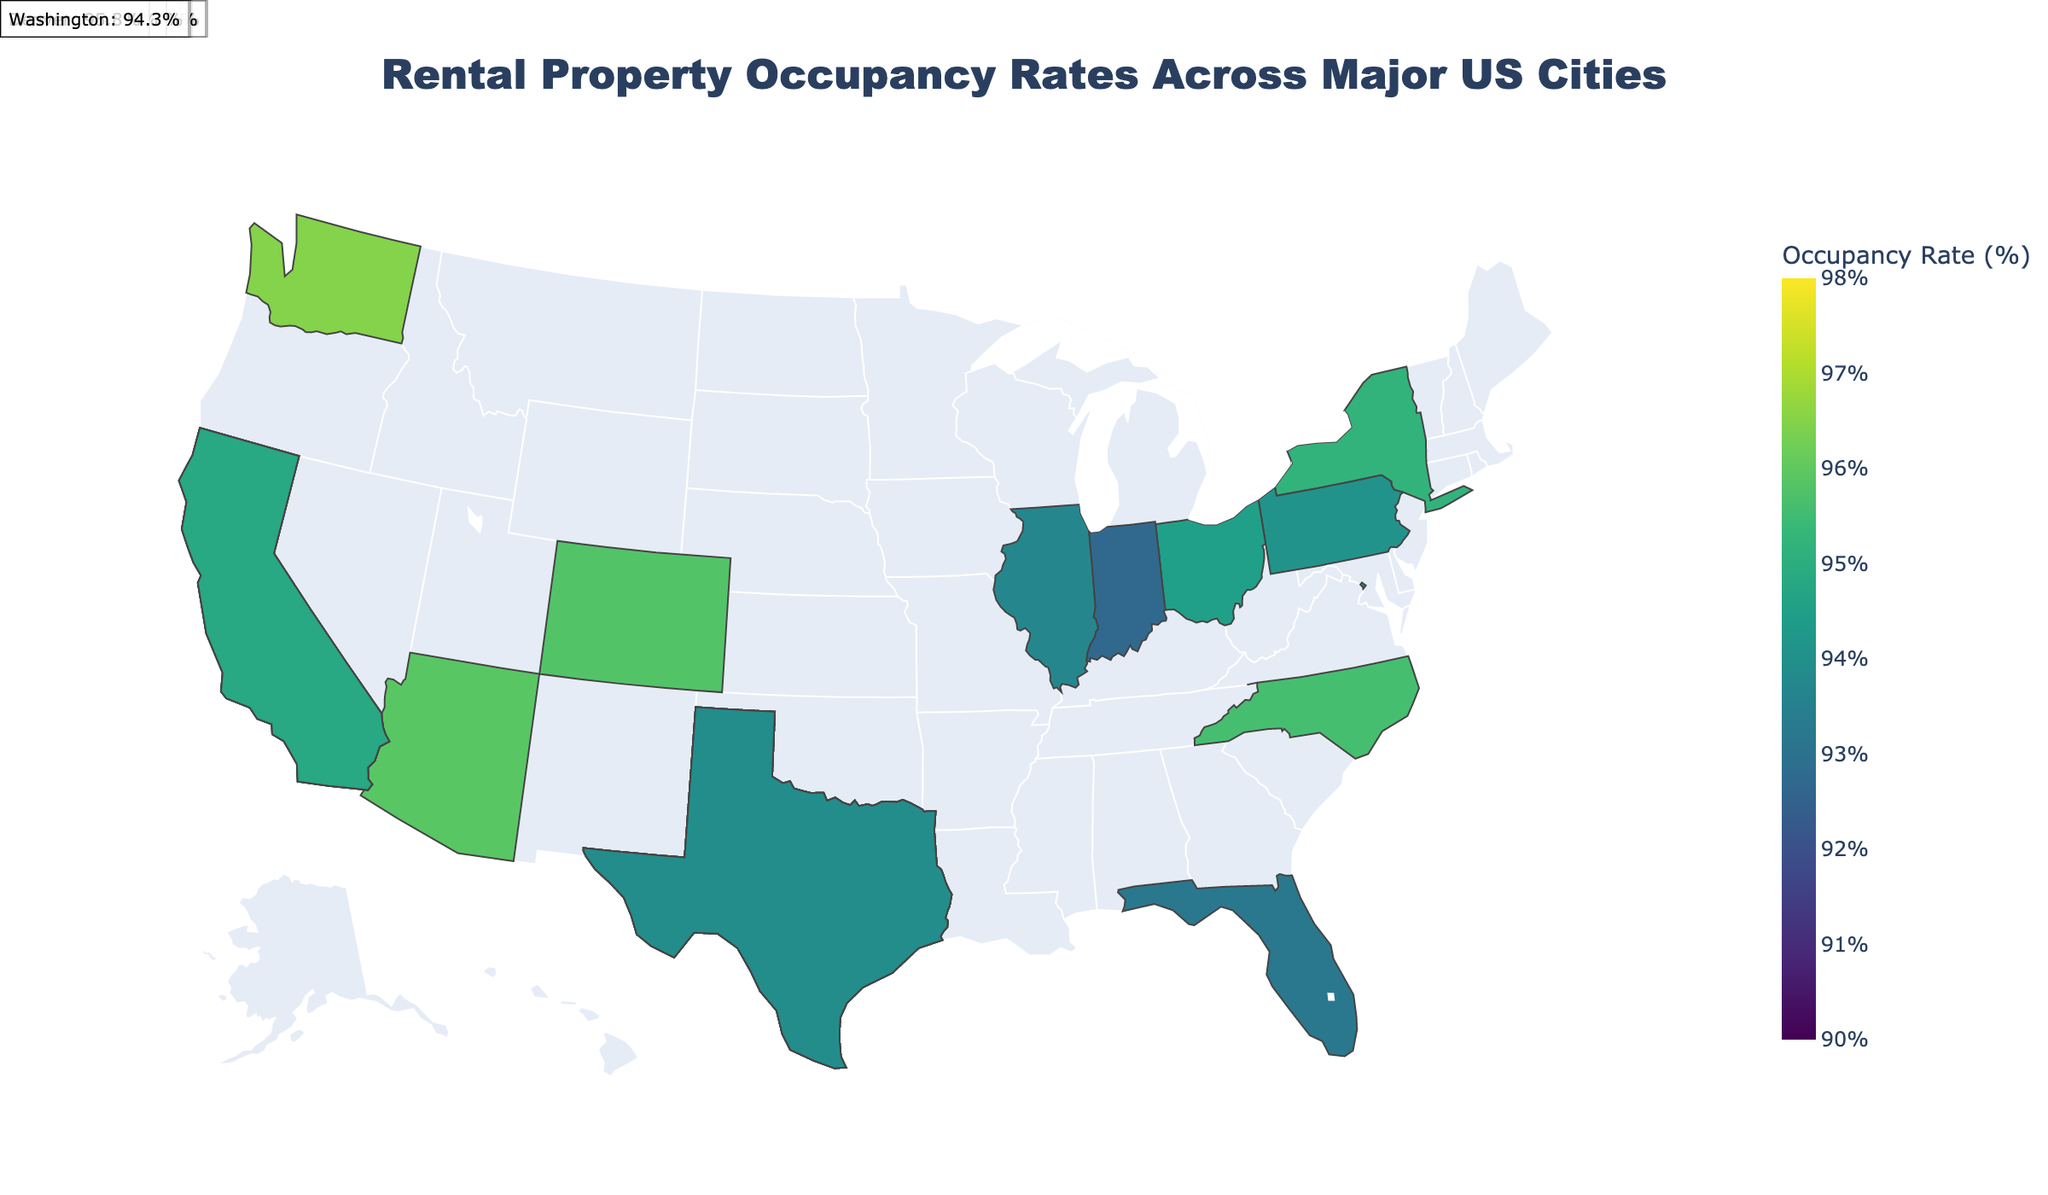what is the title of the plot? The title is displayed prominently at the top of the plot, it reads: "Rental Property Occupancy Rates Across Major US Cities".
Answer: Rental Property Occupancy Rates Across Major US Cities What state has the city with the highest rental property occupancy rate? The highest rental property occupancy rate, 97.3%, belongs to San Diego. The plot shows that San Diego is in California.
Answer: California Which city has the lowest occupancy rate, and what is the rate? By examining the annotations on the map, we see that the lowest occupancy rate is in Houston, TX, which has an occupancy rate of 91.5%.
Answer: Houston, TX, 91.5% How many cities have a rental property occupancy rate above 95%? We count the cities with rentals above 95%: Los Angeles (96.8), Phoenix (95.9), San Diego (97.3), San Jose (96.1), Austin (95.4), Charlotte (95.6), Seattle (96.5), and Denver (95.8).
Answer: 8 cities Which state has the most cities represented on the map and how many? We identify each state and count the cities: Texas has the most cities represented with Houston, San Antonio, Dallas, Fort Worth, and Austin. That's a total of 5 cities.
Answer: Texas, 5 Is the rental property occupancy rate higher on the East Coast or the West Coast? Average the occupancy rates for East Coast cities (New York City: 95.2, Philadelphia: 94.1, Washington DC: 94.3), and West Coast cities (Los Angeles: 96.8, San Diego: 97.3, San Francisco: 94.8, San Jose: 96.1, Seattle: 96.5): 
East Coast avg = (95.2 + 94.1 + 94.3) / 3 = 94.53
West Coast avg = (96.8 + 97.3 + 94.8 + 96.1 + 96.5) / 5 = 96.3
The West Coast has a higher rate.
Answer: West Coast What is the average occupancy rate across all cities? Sum all the occupancy rates and divide by the number of cities: (95.2 + 96.8 + 93.7 + 91.5 + 95.9 + 94.1 + 92.8 + 97.3 + 94.6 + 96.1 + 95.4 + 93.2 + 94.8 + 94.5 + 93.9 + 92.7 + 95.6 + 96.5 + 95.8) / 19 = 94.9%
Answer: 94.9% Which city in California has the second highest occupancy rate? California cities listed are Los Angeles (96.8), San Diego (97.3), San Francisco (94.8), and San Jose (96.1). The second highest is Los Angeles with 96.8%.
Answer: Los Angeles Do any cities have an occupancy rate between 92.5% and 93.5%? The cities which fall within this range are Chicago (93.7), Jacksonville (93.2), and Indianapolis (92.7). Out of these, Jacksonville has an occupancy rate between the specified range (93.2%).
Answer: Jacksonville (93.2%) 